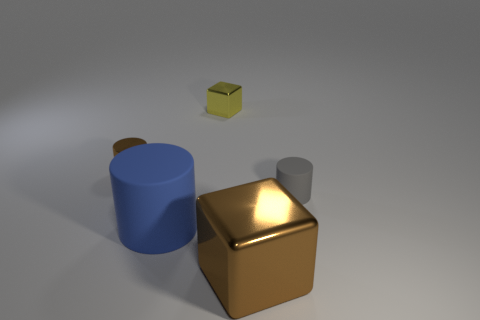Imagine this is a scene from a story. What sort of story could this setting belong to? This scene, with its clean lines and simple geometric shapes, could befit a futuristic or minimalist story. The lack of context and the surreal alignment of objects floating could suggest a scene from a science fiction narrative or a tale that explores abstract concepts and alternate realities. 